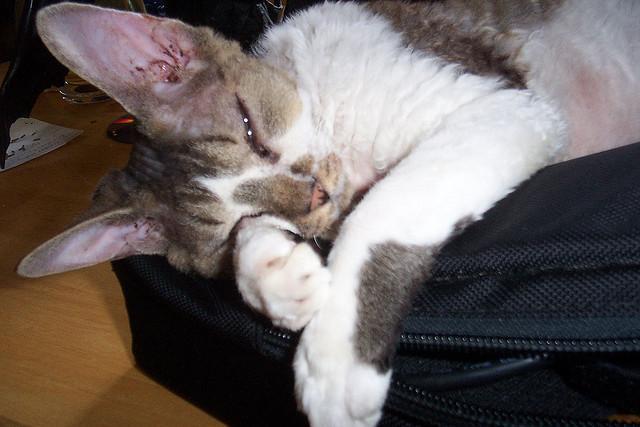How many red cars are there?
Give a very brief answer. 0. 